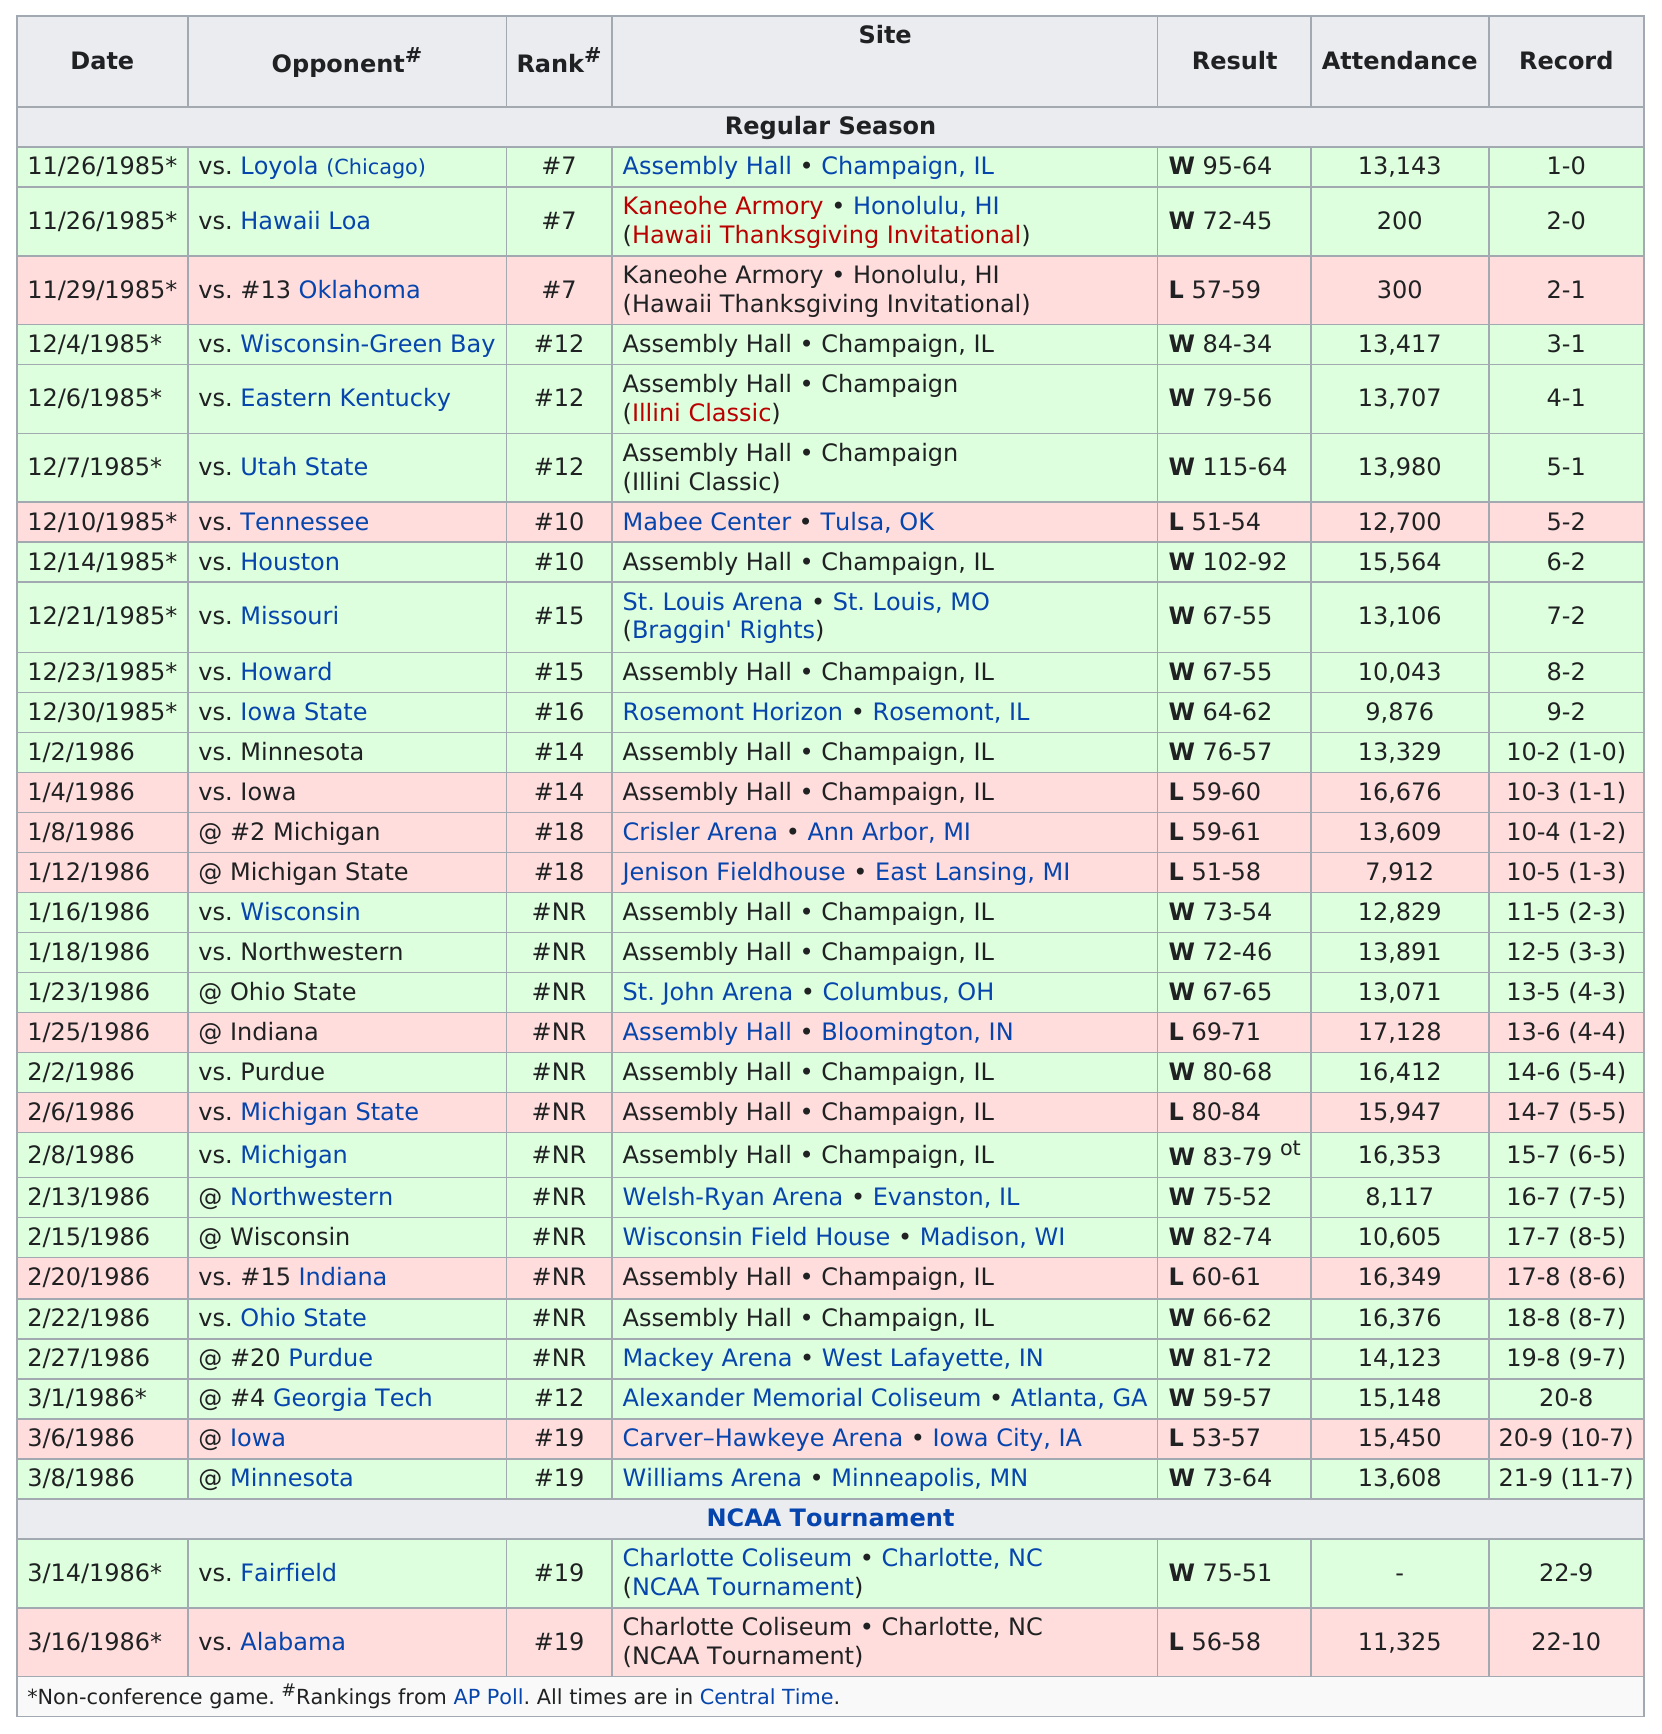List a handful of essential elements in this visual. The total number of people who attended the first game of the season was 13,143. In total, 32 games were played. In the 1985/1986 season, the longest winning streak recorded by the University of Illinois football team was 5 games. The total number of wins for this season is 22. Of the games played by the Illinois team, 20 were ranked 